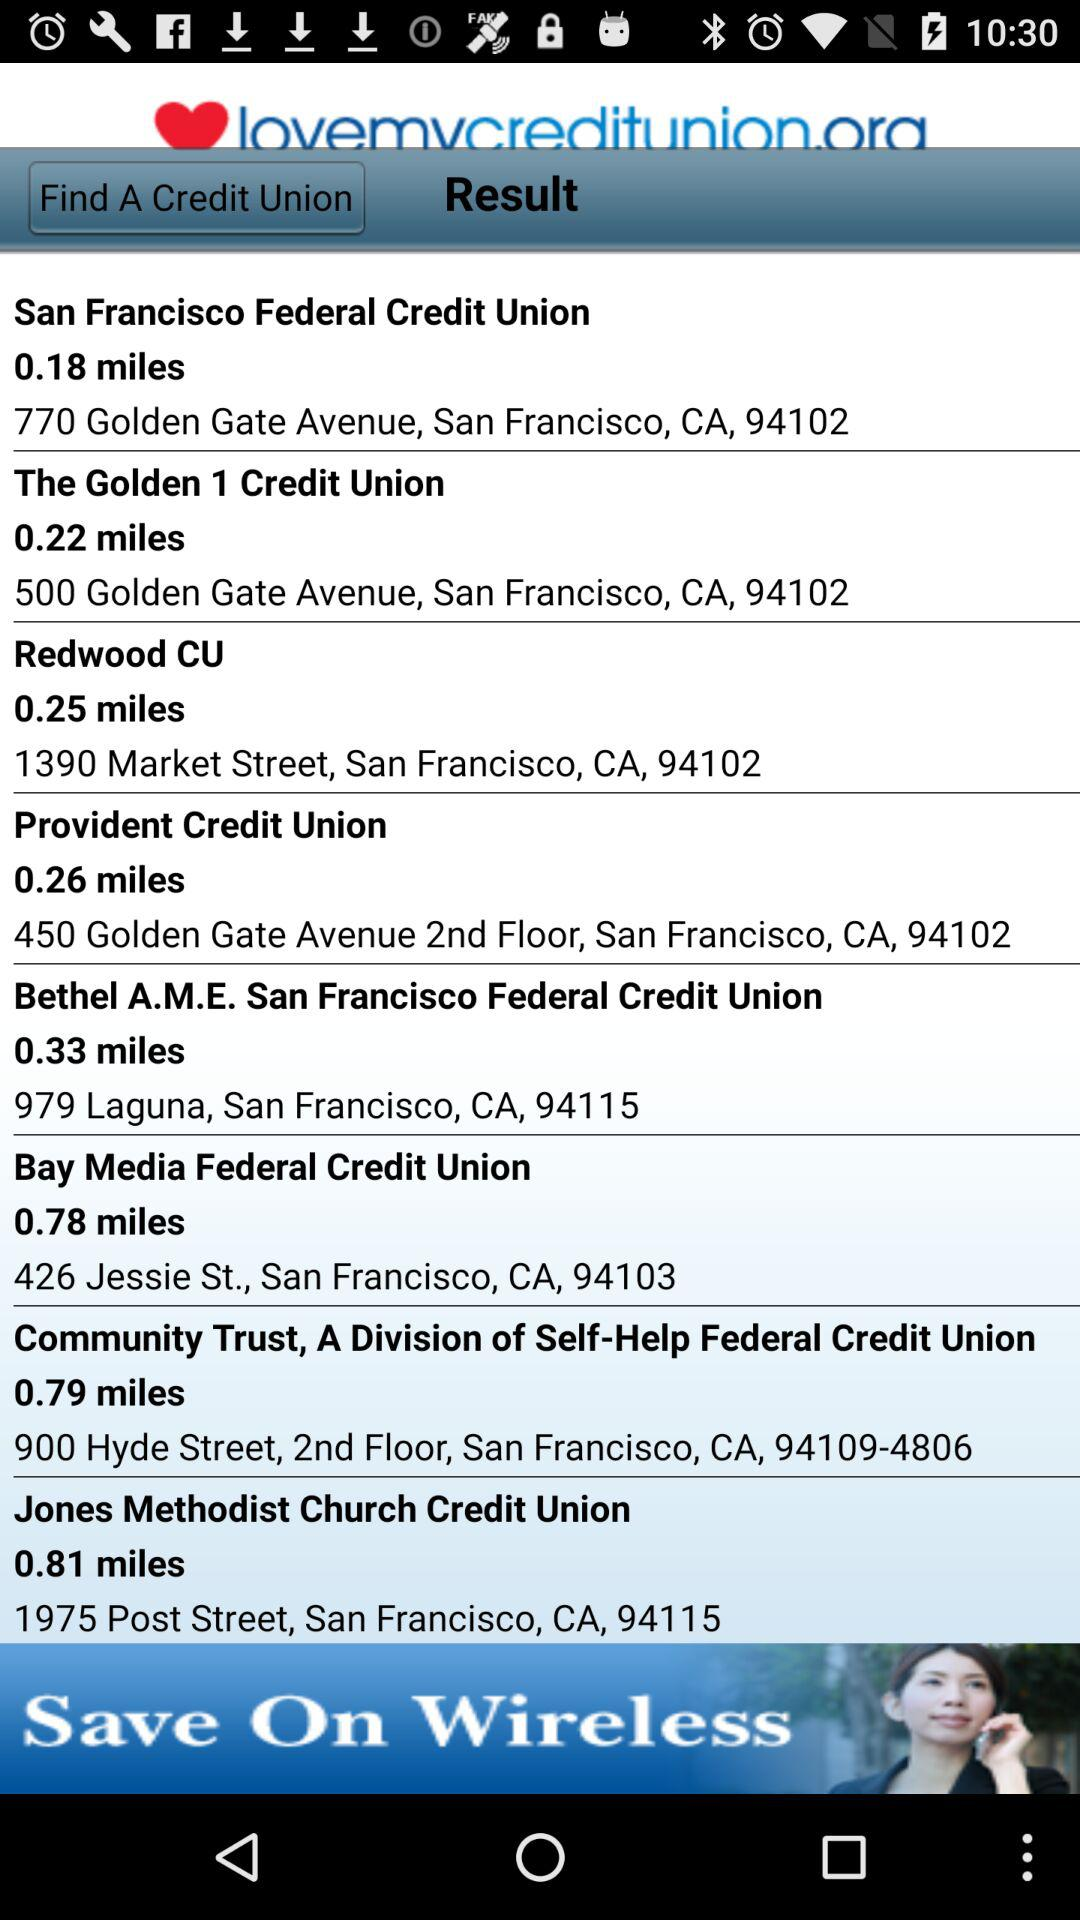What is the address of the "Provident Credit Union"? The address of the "Provident Credit Union" is 450 Golden Gate Avenue, 2nd Floor, San Francisco, CA, 94102. 